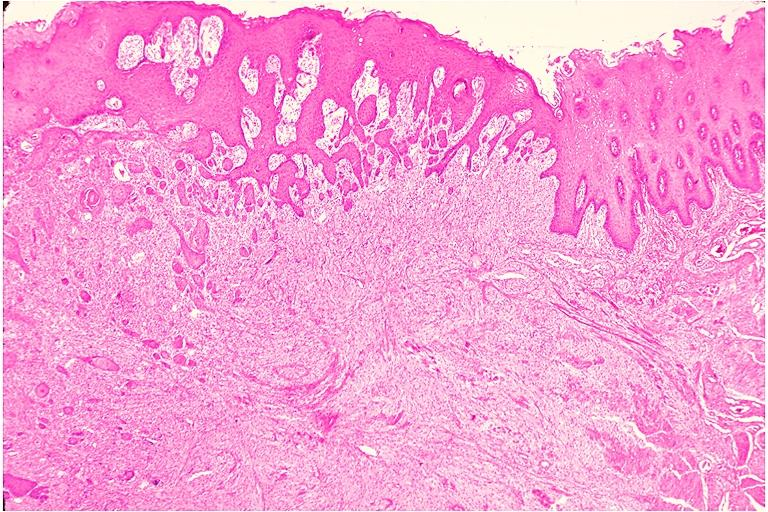s muscle present?
Answer the question using a single word or phrase. No 